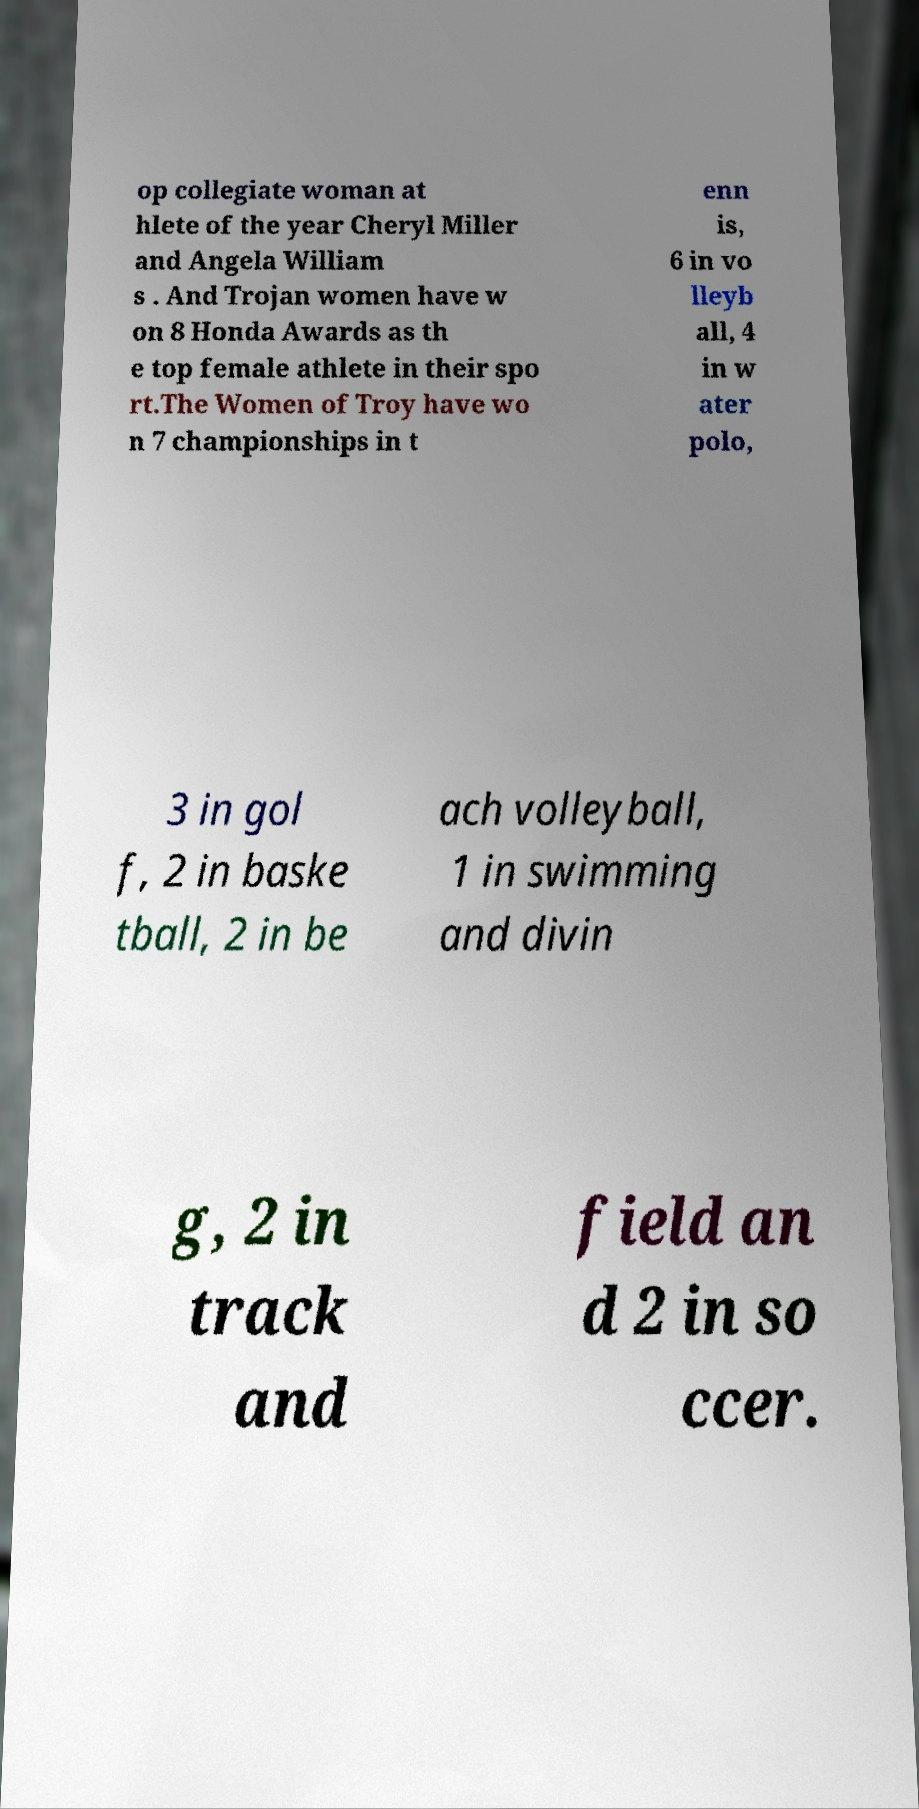Could you extract and type out the text from this image? op collegiate woman at hlete of the year Cheryl Miller and Angela William s . And Trojan women have w on 8 Honda Awards as th e top female athlete in their spo rt.The Women of Troy have wo n 7 championships in t enn is, 6 in vo lleyb all, 4 in w ater polo, 3 in gol f, 2 in baske tball, 2 in be ach volleyball, 1 in swimming and divin g, 2 in track and field an d 2 in so ccer. 